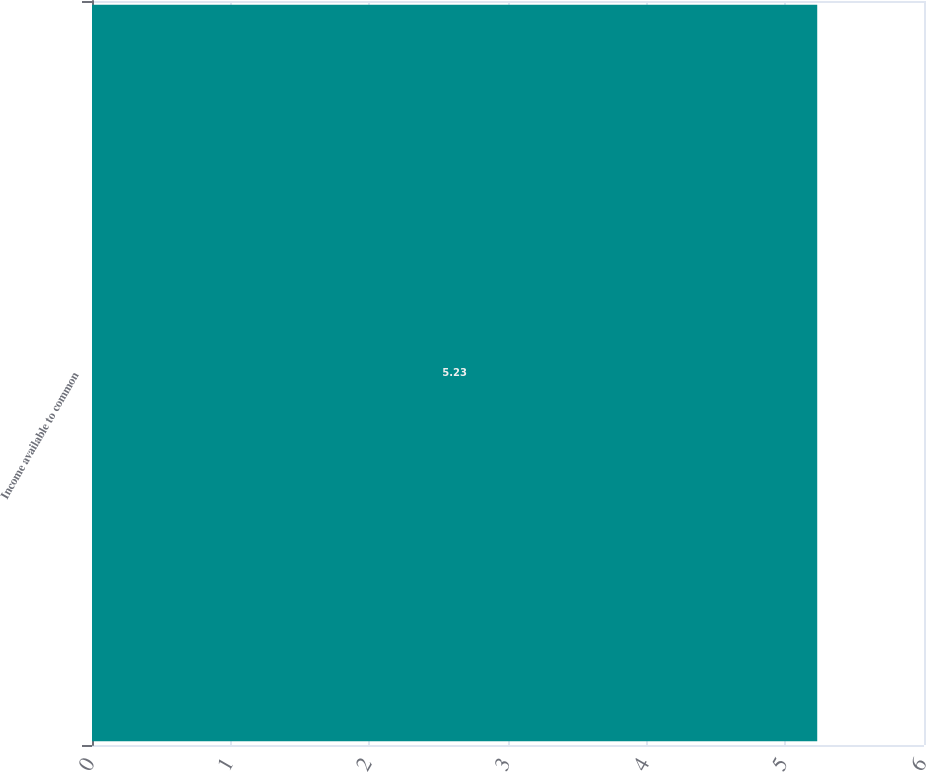Convert chart to OTSL. <chart><loc_0><loc_0><loc_500><loc_500><bar_chart><fcel>Income available to common<nl><fcel>5.23<nl></chart> 